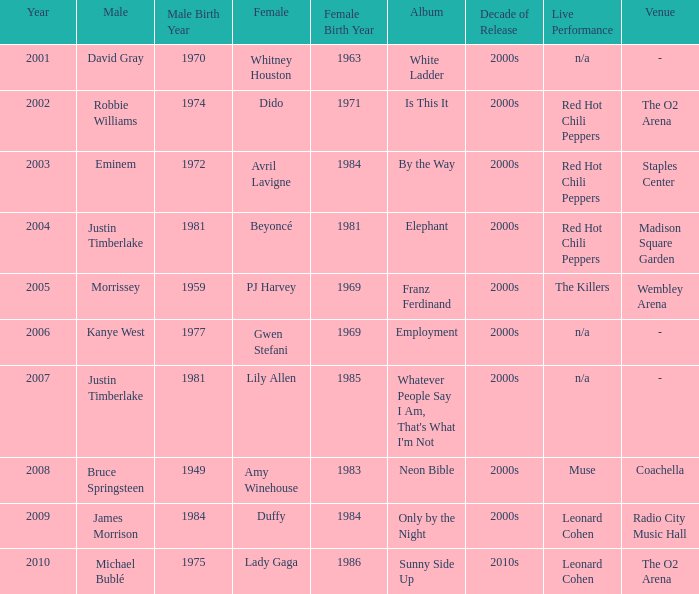Could you parse the entire table as a dict? {'header': ['Year', 'Male', 'Male Birth Year', 'Female', 'Female Birth Year', 'Album', 'Decade of Release', 'Live Performance', 'Venue'], 'rows': [['2001', 'David Gray', '1970', 'Whitney Houston', '1963', 'White Ladder', '2000s', 'n/a', '-'], ['2002', 'Robbie Williams', '1974', 'Dido', '1971', 'Is This It', '2000s', 'Red Hot Chili Peppers', 'The O2 Arena'], ['2003', 'Eminem', '1972', 'Avril Lavigne', '1984', 'By the Way', '2000s', 'Red Hot Chili Peppers', 'Staples Center'], ['2004', 'Justin Timberlake', '1981', 'Beyoncé', '1981', 'Elephant', '2000s', 'Red Hot Chili Peppers', 'Madison Square Garden'], ['2005', 'Morrissey', '1959', 'PJ Harvey', '1969', 'Franz Ferdinand', '2000s', 'The Killers', 'Wembley Arena'], ['2006', 'Kanye West', '1977', 'Gwen Stefani', '1969', 'Employment', '2000s', 'n/a', '-'], ['2007', 'Justin Timberlake', '1981', 'Lily Allen', '1985', "Whatever People Say I Am, That's What I'm Not", '2000s', 'n/a', '-'], ['2008', 'Bruce Springsteen', '1949', 'Amy Winehouse', '1983', 'Neon Bible', '2000s', 'Muse', 'Coachella'], ['2009', 'James Morrison', '1984', 'Duffy', '1984', 'Only by the Night', '2000s', 'Leonard Cohen', 'Radio City Music Hall'], ['2010', 'Michael Bublé', '1975', 'Lady Gaga', '1986', 'Sunny Side Up', '2010s', 'Leonard Cohen', 'The O2 Arena']]} Which female artist has an album named elephant? Beyoncé. 